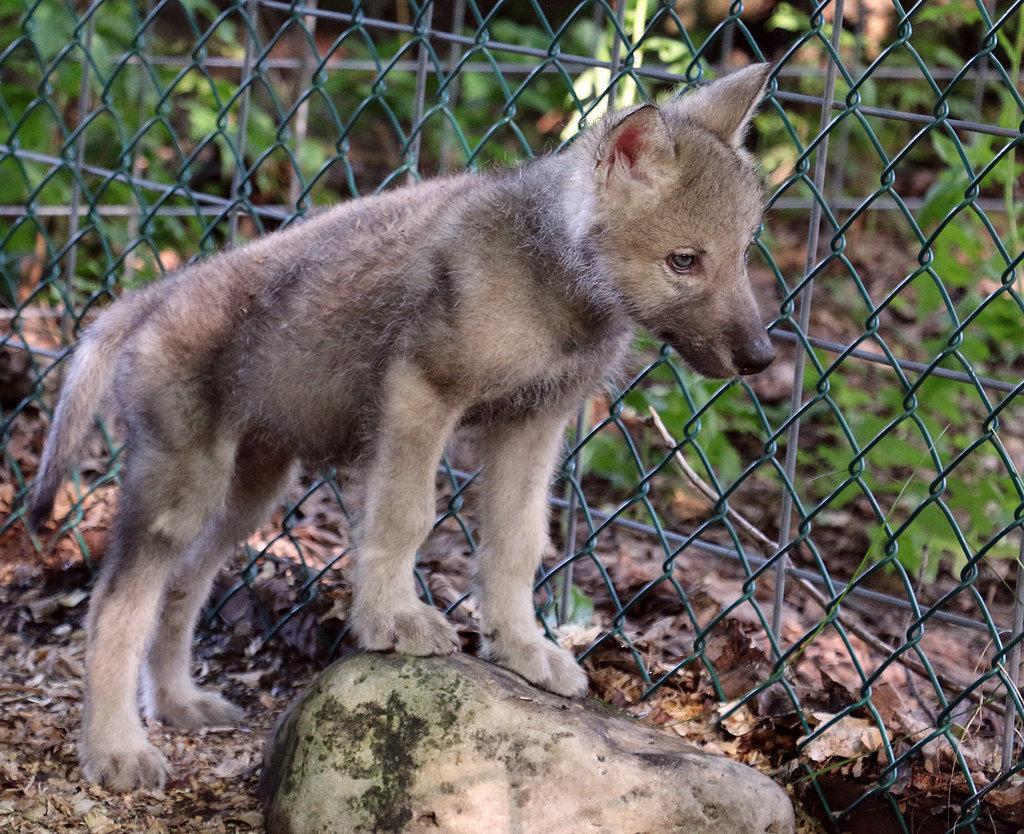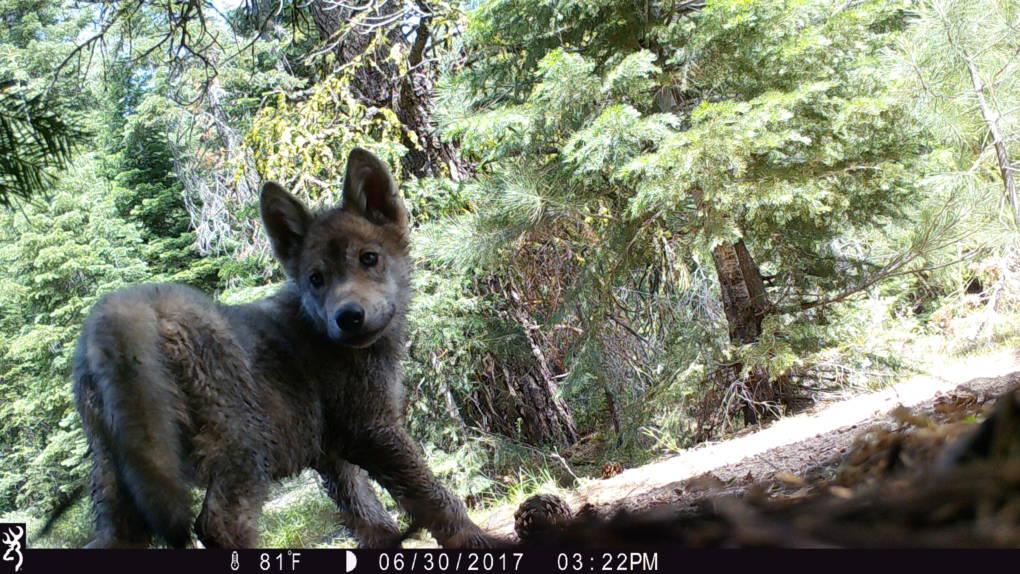The first image is the image on the left, the second image is the image on the right. Assess this claim about the two images: "The right image contains one wolf, a pup standing in front of trees with its body turned rightward.". Correct or not? Answer yes or no. Yes. The first image is the image on the left, the second image is the image on the right. For the images displayed, is the sentence "There are multiple animals in the wild in the image on the left." factually correct? Answer yes or no. No. 